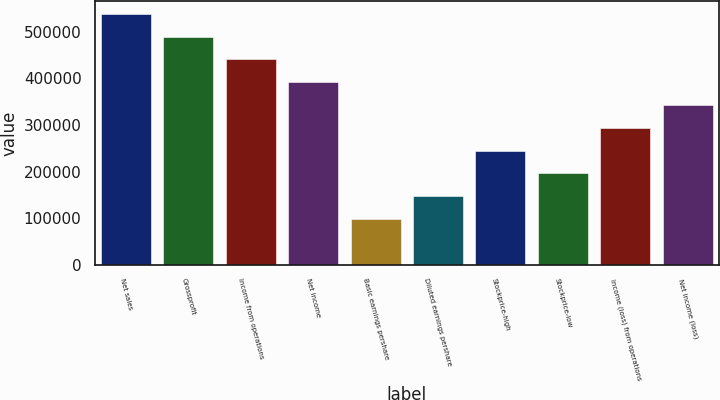<chart> <loc_0><loc_0><loc_500><loc_500><bar_chart><fcel>Net sales<fcel>Grossprofit<fcel>Income from operations<fcel>Net income<fcel>Basic earnings pershare<fcel>Diluted earnings pershare<fcel>Stockprice-high<fcel>Stockprice-low<fcel>Income (loss) from operations<fcel>Net income (loss)<nl><fcel>538381<fcel>489437<fcel>440493<fcel>391550<fcel>97887.4<fcel>146831<fcel>244719<fcel>195775<fcel>293662<fcel>342606<nl></chart> 